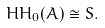<formula> <loc_0><loc_0><loc_500><loc_500>H H _ { 0 } ( A ) \cong S .</formula> 